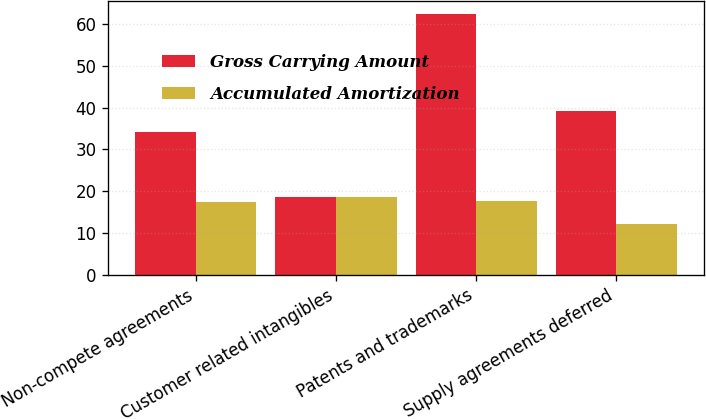Convert chart to OTSL. <chart><loc_0><loc_0><loc_500><loc_500><stacked_bar_chart><ecel><fcel>Non-compete agreements<fcel>Customer related intangibles<fcel>Patents and trademarks<fcel>Supply agreements deferred<nl><fcel>Gross Carrying Amount<fcel>34.2<fcel>18.5<fcel>62.4<fcel>39.2<nl><fcel>Accumulated Amortization<fcel>17.5<fcel>18.5<fcel>17.7<fcel>12.2<nl></chart> 